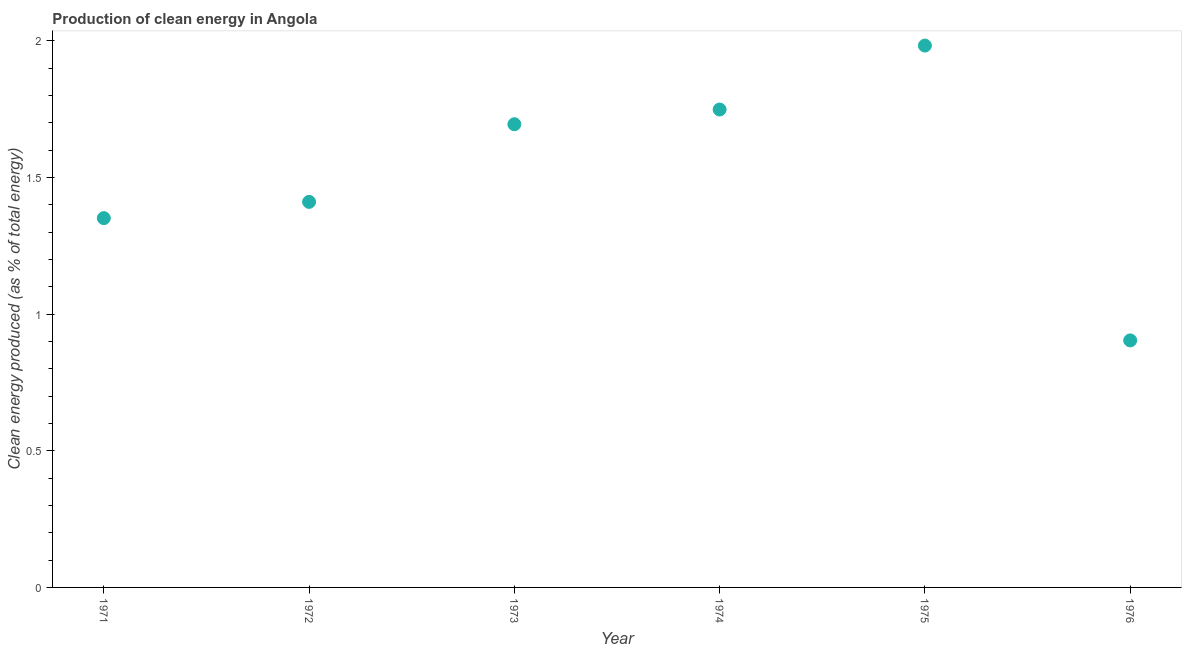What is the production of clean energy in 1976?
Offer a very short reply. 0.9. Across all years, what is the maximum production of clean energy?
Your answer should be very brief. 1.98. Across all years, what is the minimum production of clean energy?
Ensure brevity in your answer.  0.9. In which year was the production of clean energy maximum?
Your answer should be compact. 1975. In which year was the production of clean energy minimum?
Offer a very short reply. 1976. What is the sum of the production of clean energy?
Provide a short and direct response. 9.09. What is the difference between the production of clean energy in 1971 and 1975?
Your answer should be compact. -0.63. What is the average production of clean energy per year?
Your response must be concise. 1.52. What is the median production of clean energy?
Provide a short and direct response. 1.55. What is the ratio of the production of clean energy in 1973 to that in 1976?
Ensure brevity in your answer.  1.88. Is the production of clean energy in 1973 less than that in 1974?
Keep it short and to the point. Yes. What is the difference between the highest and the second highest production of clean energy?
Offer a very short reply. 0.23. Is the sum of the production of clean energy in 1974 and 1976 greater than the maximum production of clean energy across all years?
Provide a succinct answer. Yes. What is the difference between the highest and the lowest production of clean energy?
Your answer should be very brief. 1.08. In how many years, is the production of clean energy greater than the average production of clean energy taken over all years?
Your response must be concise. 3. What is the difference between two consecutive major ticks on the Y-axis?
Your answer should be very brief. 0.5. Are the values on the major ticks of Y-axis written in scientific E-notation?
Offer a very short reply. No. Does the graph contain any zero values?
Your response must be concise. No. What is the title of the graph?
Offer a very short reply. Production of clean energy in Angola. What is the label or title of the Y-axis?
Keep it short and to the point. Clean energy produced (as % of total energy). What is the Clean energy produced (as % of total energy) in 1971?
Your answer should be compact. 1.35. What is the Clean energy produced (as % of total energy) in 1972?
Offer a terse response. 1.41. What is the Clean energy produced (as % of total energy) in 1973?
Your answer should be very brief. 1.69. What is the Clean energy produced (as % of total energy) in 1974?
Provide a short and direct response. 1.75. What is the Clean energy produced (as % of total energy) in 1975?
Your answer should be very brief. 1.98. What is the Clean energy produced (as % of total energy) in 1976?
Provide a succinct answer. 0.9. What is the difference between the Clean energy produced (as % of total energy) in 1971 and 1972?
Ensure brevity in your answer.  -0.06. What is the difference between the Clean energy produced (as % of total energy) in 1971 and 1973?
Your answer should be very brief. -0.34. What is the difference between the Clean energy produced (as % of total energy) in 1971 and 1974?
Provide a short and direct response. -0.4. What is the difference between the Clean energy produced (as % of total energy) in 1971 and 1975?
Offer a very short reply. -0.63. What is the difference between the Clean energy produced (as % of total energy) in 1971 and 1976?
Offer a very short reply. 0.45. What is the difference between the Clean energy produced (as % of total energy) in 1972 and 1973?
Ensure brevity in your answer.  -0.28. What is the difference between the Clean energy produced (as % of total energy) in 1972 and 1974?
Offer a terse response. -0.34. What is the difference between the Clean energy produced (as % of total energy) in 1972 and 1975?
Your answer should be compact. -0.57. What is the difference between the Clean energy produced (as % of total energy) in 1972 and 1976?
Make the answer very short. 0.51. What is the difference between the Clean energy produced (as % of total energy) in 1973 and 1974?
Offer a terse response. -0.05. What is the difference between the Clean energy produced (as % of total energy) in 1973 and 1975?
Offer a very short reply. -0.29. What is the difference between the Clean energy produced (as % of total energy) in 1973 and 1976?
Offer a very short reply. 0.79. What is the difference between the Clean energy produced (as % of total energy) in 1974 and 1975?
Ensure brevity in your answer.  -0.23. What is the difference between the Clean energy produced (as % of total energy) in 1974 and 1976?
Provide a succinct answer. 0.84. What is the difference between the Clean energy produced (as % of total energy) in 1975 and 1976?
Give a very brief answer. 1.08. What is the ratio of the Clean energy produced (as % of total energy) in 1971 to that in 1972?
Give a very brief answer. 0.96. What is the ratio of the Clean energy produced (as % of total energy) in 1971 to that in 1973?
Your answer should be compact. 0.8. What is the ratio of the Clean energy produced (as % of total energy) in 1971 to that in 1974?
Offer a terse response. 0.77. What is the ratio of the Clean energy produced (as % of total energy) in 1971 to that in 1975?
Offer a terse response. 0.68. What is the ratio of the Clean energy produced (as % of total energy) in 1971 to that in 1976?
Provide a short and direct response. 1.5. What is the ratio of the Clean energy produced (as % of total energy) in 1972 to that in 1973?
Make the answer very short. 0.83. What is the ratio of the Clean energy produced (as % of total energy) in 1972 to that in 1974?
Your answer should be compact. 0.81. What is the ratio of the Clean energy produced (as % of total energy) in 1972 to that in 1975?
Keep it short and to the point. 0.71. What is the ratio of the Clean energy produced (as % of total energy) in 1972 to that in 1976?
Provide a short and direct response. 1.56. What is the ratio of the Clean energy produced (as % of total energy) in 1973 to that in 1974?
Offer a very short reply. 0.97. What is the ratio of the Clean energy produced (as % of total energy) in 1973 to that in 1975?
Make the answer very short. 0.85. What is the ratio of the Clean energy produced (as % of total energy) in 1973 to that in 1976?
Offer a terse response. 1.88. What is the ratio of the Clean energy produced (as % of total energy) in 1974 to that in 1975?
Offer a very short reply. 0.88. What is the ratio of the Clean energy produced (as % of total energy) in 1974 to that in 1976?
Keep it short and to the point. 1.94. What is the ratio of the Clean energy produced (as % of total energy) in 1975 to that in 1976?
Offer a very short reply. 2.19. 